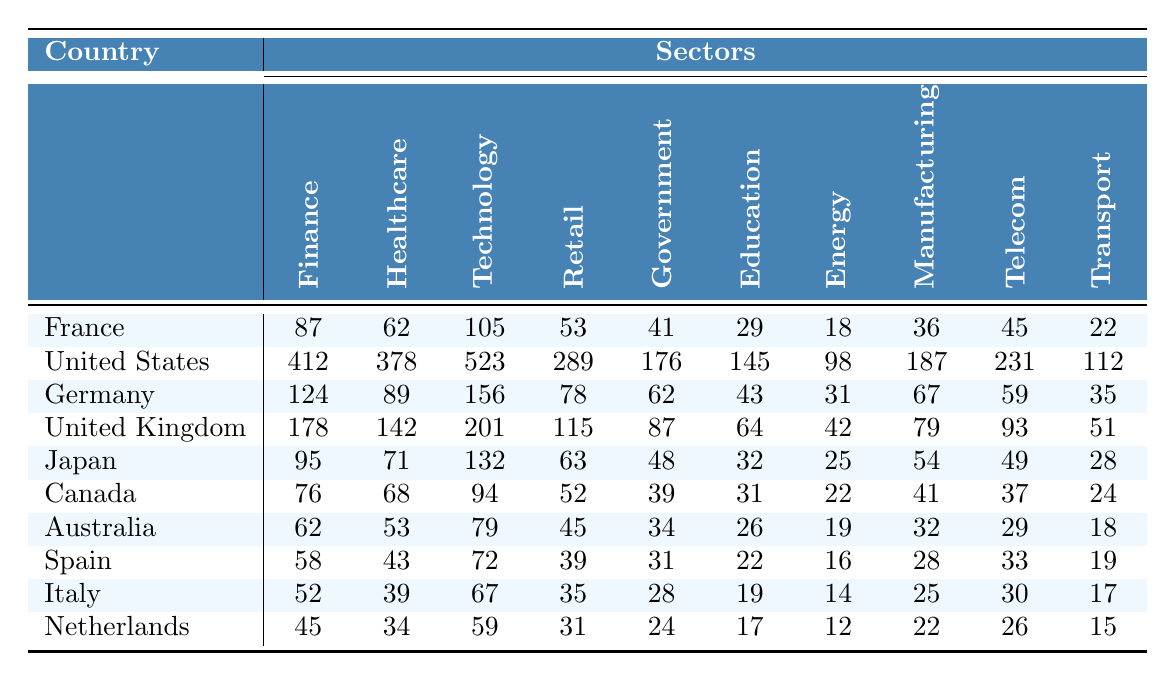What is the number of data breaches in the Technology sector for France? In the table, the value for France under the Technology sector is listed as 105.
Answer: 105 Which country had the highest number of data breaches in the Healthcare sector? By comparing the values in the Healthcare sector across all countries, the United States has the highest value of 378.
Answer: United States What is the total number of data breaches in the Retail sector for all countries combined? To find the total, sum the values in the Retail sector: (53 + 289 + 78 + 115 + 63 + 52 + 45 + 39 + 35 + 31) = 840.
Answer: 840 What is the difference in the number of data breaches between the Technology and Government sectors for Germany? For Germany, the Technology sector has 156 breaches and the Government sector has 62. The difference is calculated as 156 - 62 = 94.
Answer: 94 Which country has fewer data breaches in the Education sector, Canada or Australia? Canada has 31 breaches while Australia has 26. Since 26 is less than 31, Australia has fewer breaches.
Answer: Australia How many data breaches were recorded in the Transport sector for the United States? The table shows that the United States recorded 112 breaches in the Transport sector.
Answer: 112 What is the average number of data breaches in the Energy sector across all countries? To find the average, first sum the values: (18 + 98 + 31 + 42 + 25 + 22 + 19 + 16 + 14 + 12) =  357. There are 10 countries, so the average is 357 / 10 = 35.7.
Answer: 35.7 True or False: The number of data breaches in the Finance sector is greater than that in the Technology sector for Japan. Japan has 95 breaches in the Finance sector and 132 in the Technology sector. Since 95 is less than 132, the statement is false.
Answer: False Which country has the least number of data breaches in the Government sector? By comparing the values in the Government sector, Spain has the least with 31 breaches.
Answer: Spain What is the total number of data breaches for the top 3 countries in the Technology sector? The top 3 countries in the Technology sector and their values are: United States (523), Germany (156), and United Kingdom (201). Summing these gives 523 + 156 + 201 = 880.
Answer: 880 